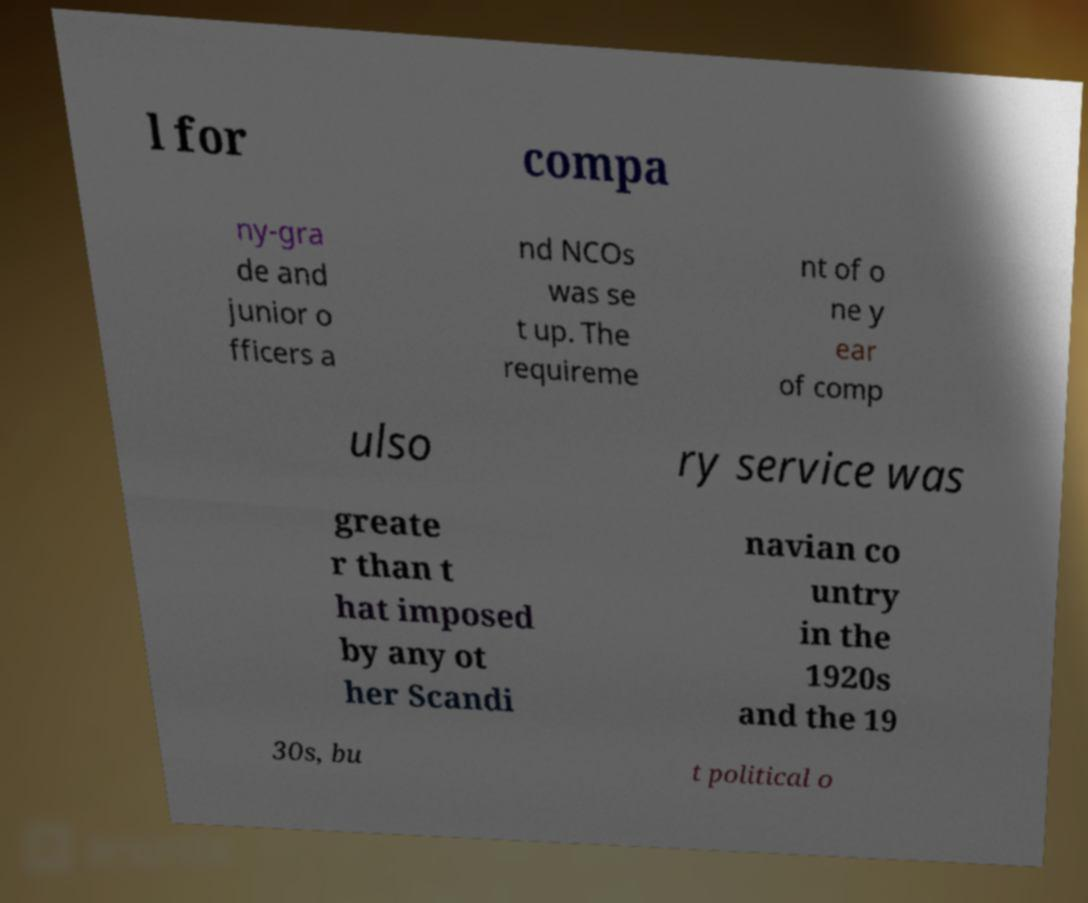There's text embedded in this image that I need extracted. Can you transcribe it verbatim? l for compa ny-gra de and junior o fficers a nd NCOs was se t up. The requireme nt of o ne y ear of comp ulso ry service was greate r than t hat imposed by any ot her Scandi navian co untry in the 1920s and the 19 30s, bu t political o 